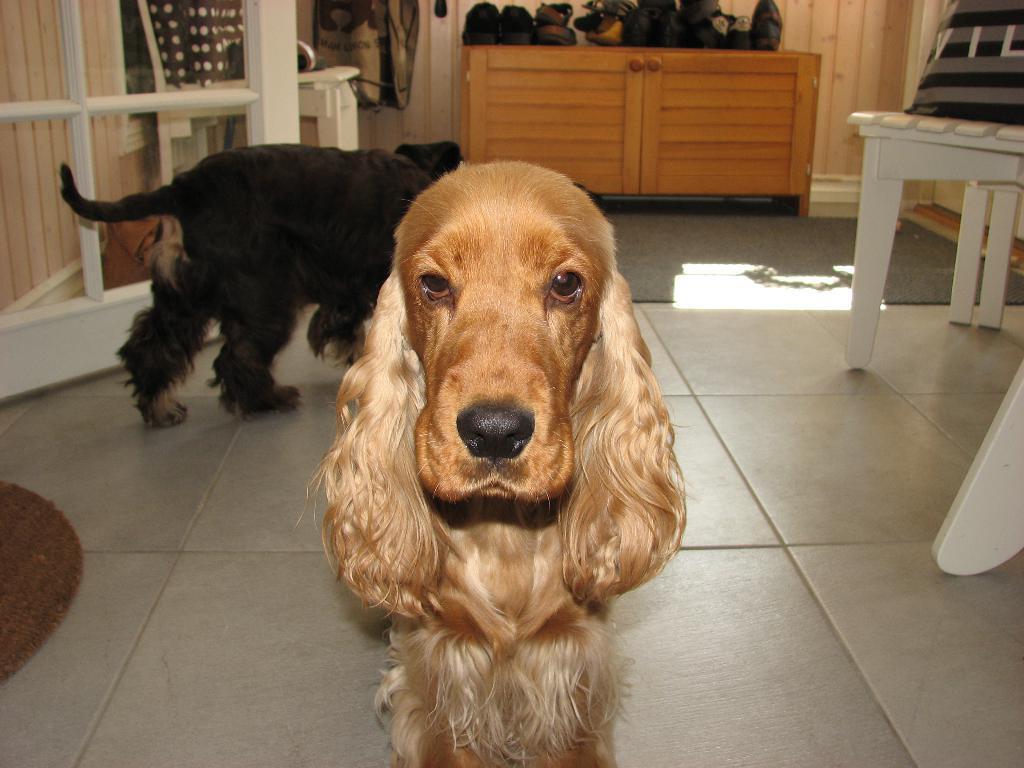Please provide a concise description of this image. In this image there is a floor towards the bottom of the image, there are mats on the floor, there are two dogs, there is a door towards the left of the image, there is a wall towards the left of the image, there is a chair towards the right of the image, there is a pillow towards the right of the image, there are objects towards the top of the image, there is a wall towards the top of the image, there is an object that looks like a cupboard, there are objects on the cupboard. 